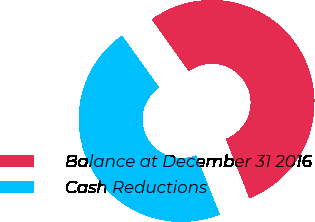<chart> <loc_0><loc_0><loc_500><loc_500><pie_chart><fcel>Balance at December 31 2016<fcel>Cash Reductions<nl><fcel>53.85%<fcel>46.15%<nl></chart> 